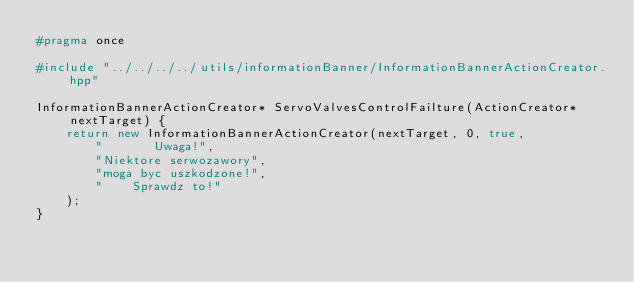Convert code to text. <code><loc_0><loc_0><loc_500><loc_500><_C++_>#pragma once

#include "../../../../utils/informationBanner/InformationBannerActionCreator.hpp"

InformationBannerActionCreator* ServoValvesControlFailture(ActionCreator* nextTarget) {
    return new InformationBannerActionCreator(nextTarget, 0, true,
        "       Uwaga!",
        "Niektore serwozawory",
        "moga byc uszkodzone!",
        "    Sprawdz to!"
    );
}</code> 